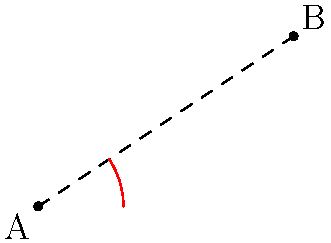In the context of a community-focused app for efficient navigation, you're working with a software engineer to implement a feature that calculates the shortest path between two locations in a uniquely shaped neighborhood. The neighborhood's layout can be modeled using hyperbolic geometry. On the hyperbolic plane shown, what is the nature of the shortest path between points A and B, and how does it differ from the straight line path in Euclidean geometry? To understand the shortest path in hyperbolic geometry:

1. In Euclidean geometry, the shortest path between two points is always a straight line. This is represented by the dashed line in the diagram.

2. However, in hyperbolic geometry, the shortest path between two points is a curve called a geodesic. This is represented by the red arc in the diagram.

3. The blue curve represents a hyperbola, which is a fundamental shape in hyperbolic geometry. The geodesic (shortest path) follows this hyperbolic curve.

4. The geodesic appears curved when represented in Euclidean space, but in hyperbolic space, it's actually the "straightest" possible path between the two points.

5. This curved path is shorter in hyperbolic space than the Euclidean straight line would be, even though it looks longer in our Euclidean representation.

6. The difference in path length becomes more pronounced as the distance between points increases in hyperbolic space.

For the community app, this means that the most efficient route between two locations might appear curved on a conventional map, but would actually represent the quickest path for residents to travel.
Answer: The shortest path is a curved geodesic following the hyperbolic geometry, not a straight line as in Euclidean geometry. 